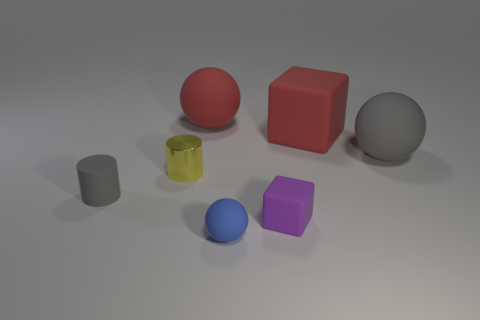Add 2 cyan things. How many objects exist? 9 Subtract all cubes. How many objects are left? 5 Add 4 small things. How many small things are left? 8 Add 4 purple matte cylinders. How many purple matte cylinders exist? 4 Subtract 1 gray cylinders. How many objects are left? 6 Subtract all rubber cylinders. Subtract all big rubber spheres. How many objects are left? 4 